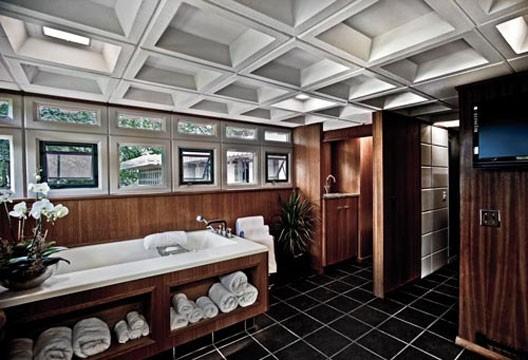How many towels are there?
Be succinct. 17. Is this a spa?
Short answer required. Yes. Where are the plants?
Give a very brief answer. In corner. 